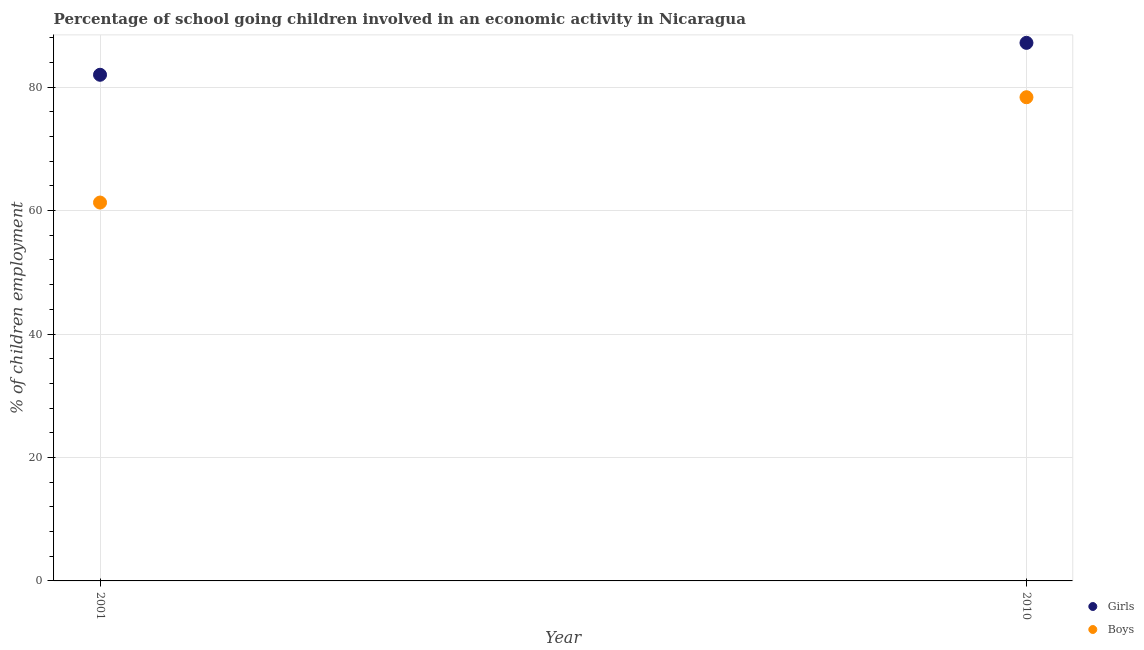How many different coloured dotlines are there?
Provide a succinct answer. 2. Is the number of dotlines equal to the number of legend labels?
Your answer should be very brief. Yes. What is the percentage of school going girls in 2010?
Your answer should be compact. 87.16. Across all years, what is the maximum percentage of school going girls?
Provide a short and direct response. 87.16. Across all years, what is the minimum percentage of school going girls?
Your answer should be very brief. 81.99. In which year was the percentage of school going girls maximum?
Keep it short and to the point. 2010. In which year was the percentage of school going girls minimum?
Provide a short and direct response. 2001. What is the total percentage of school going girls in the graph?
Provide a short and direct response. 169.16. What is the difference between the percentage of school going boys in 2001 and that in 2010?
Your response must be concise. -17.06. What is the difference between the percentage of school going boys in 2001 and the percentage of school going girls in 2010?
Make the answer very short. -25.87. What is the average percentage of school going boys per year?
Your answer should be compact. 69.83. In the year 2010, what is the difference between the percentage of school going girls and percentage of school going boys?
Keep it short and to the point. 8.81. In how many years, is the percentage of school going girls greater than 56 %?
Provide a succinct answer. 2. What is the ratio of the percentage of school going girls in 2001 to that in 2010?
Offer a very short reply. 0.94. In how many years, is the percentage of school going boys greater than the average percentage of school going boys taken over all years?
Provide a succinct answer. 1. Does the percentage of school going boys monotonically increase over the years?
Provide a short and direct response. Yes. Is the percentage of school going boys strictly less than the percentage of school going girls over the years?
Your answer should be very brief. Yes. What is the difference between two consecutive major ticks on the Y-axis?
Your answer should be very brief. 20. Are the values on the major ticks of Y-axis written in scientific E-notation?
Your answer should be very brief. No. Does the graph contain any zero values?
Your response must be concise. No. How many legend labels are there?
Offer a terse response. 2. What is the title of the graph?
Your answer should be very brief. Percentage of school going children involved in an economic activity in Nicaragua. What is the label or title of the Y-axis?
Offer a terse response. % of children employment. What is the % of children employment in Girls in 2001?
Your answer should be compact. 81.99. What is the % of children employment in Boys in 2001?
Give a very brief answer. 61.3. What is the % of children employment of Girls in 2010?
Make the answer very short. 87.16. What is the % of children employment in Boys in 2010?
Provide a short and direct response. 78.36. Across all years, what is the maximum % of children employment of Girls?
Your answer should be very brief. 87.16. Across all years, what is the maximum % of children employment in Boys?
Your answer should be very brief. 78.36. Across all years, what is the minimum % of children employment of Girls?
Give a very brief answer. 81.99. Across all years, what is the minimum % of children employment of Boys?
Ensure brevity in your answer.  61.3. What is the total % of children employment of Girls in the graph?
Give a very brief answer. 169.16. What is the total % of children employment of Boys in the graph?
Keep it short and to the point. 139.65. What is the difference between the % of children employment of Girls in 2001 and that in 2010?
Your answer should be very brief. -5.17. What is the difference between the % of children employment of Boys in 2001 and that in 2010?
Provide a succinct answer. -17.06. What is the difference between the % of children employment in Girls in 2001 and the % of children employment in Boys in 2010?
Your answer should be compact. 3.64. What is the average % of children employment of Girls per year?
Offer a terse response. 84.58. What is the average % of children employment in Boys per year?
Your answer should be very brief. 69.83. In the year 2001, what is the difference between the % of children employment in Girls and % of children employment in Boys?
Keep it short and to the point. 20.7. In the year 2010, what is the difference between the % of children employment in Girls and % of children employment in Boys?
Provide a succinct answer. 8.81. What is the ratio of the % of children employment in Girls in 2001 to that in 2010?
Offer a terse response. 0.94. What is the ratio of the % of children employment in Boys in 2001 to that in 2010?
Provide a short and direct response. 0.78. What is the difference between the highest and the second highest % of children employment of Girls?
Provide a succinct answer. 5.17. What is the difference between the highest and the second highest % of children employment of Boys?
Keep it short and to the point. 17.06. What is the difference between the highest and the lowest % of children employment of Girls?
Provide a short and direct response. 5.17. What is the difference between the highest and the lowest % of children employment of Boys?
Offer a terse response. 17.06. 